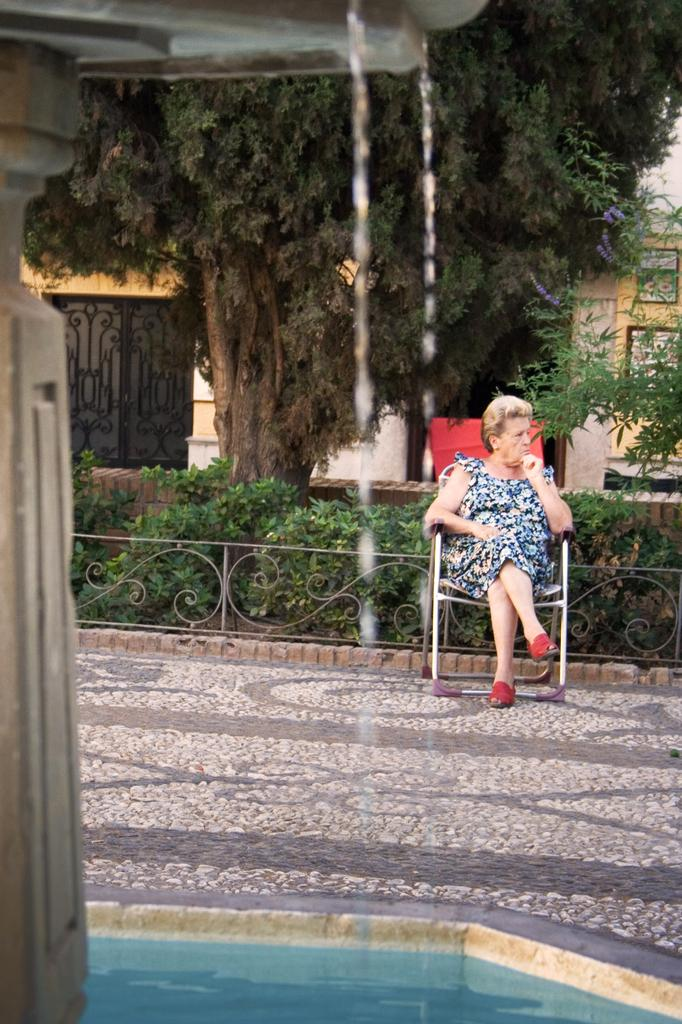What is the main feature in the image? There is a swimming pool in the image. What is the surface on which the swimming pool is located? There is a floor in the image. Who is present in the image? There is an old woman sitting on a chair in the image. What type of vegetation can be seen in the image? There are green color plants in the image. What other natural element is visible in the image? There is a tree in the image. How does the fact change the pump's behavior in the image? There is no fact or pump present in the image, so this question cannot be answered. 